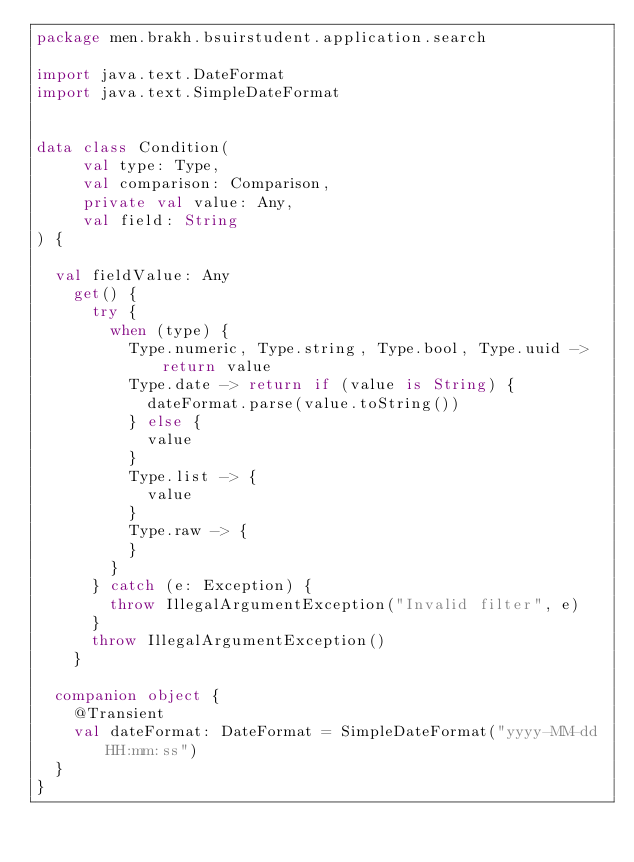<code> <loc_0><loc_0><loc_500><loc_500><_Kotlin_>package men.brakh.bsuirstudent.application.search

import java.text.DateFormat
import java.text.SimpleDateFormat


data class Condition(
     val type: Type,
     val comparison: Comparison,
     private val value: Any,
     val field: String
) {

  val fieldValue: Any
    get() {
      try {
        when (type) {
          Type.numeric, Type.string, Type.bool, Type.uuid -> return value
          Type.date -> return if (value is String) {
            dateFormat.parse(value.toString())
          } else {
            value
          }
          Type.list -> {
            value
          }
          Type.raw -> {
          }
        }
      } catch (e: Exception) {
        throw IllegalArgumentException("Invalid filter", e)
      }
      throw IllegalArgumentException()
    }

  companion object {
    @Transient
    val dateFormat: DateFormat = SimpleDateFormat("yyyy-MM-dd HH:mm:ss")
  }
}</code> 